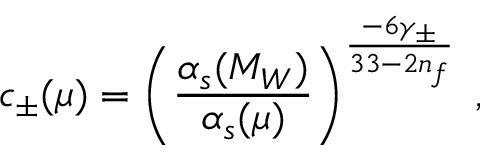Convert formula to latex. <formula><loc_0><loc_0><loc_500><loc_500>c _ { \pm } ( \mu ) = \left ( \frac { \alpha _ { s } ( M _ { W } ) } { \alpha _ { s } ( \mu ) } \right ) ^ { \frac { - 6 \gamma _ { \pm } } { 3 3 - 2 n _ { f } } } \, ,</formula> 